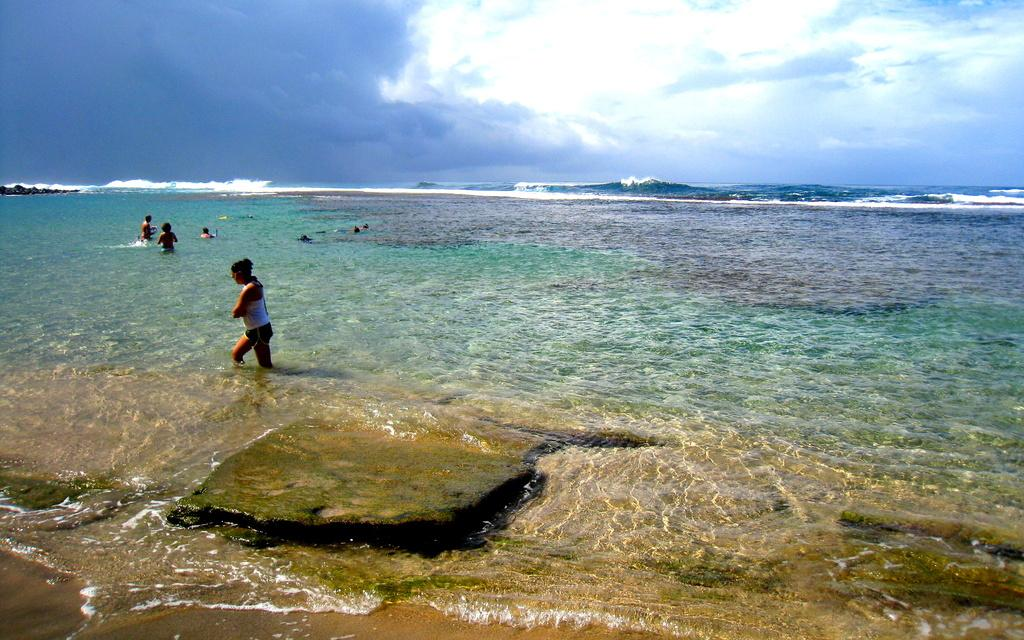What are the people in the image doing? The people in the image are in the water. What can be seen in the background of the image? The sky is visible in the background of the image. What is the condition of the sky in the image? Clouds are present in the sky. What type of branch can be seen growing from the yam in the image? There is no branch or yam present in the image; it features people in the water with a visible sky and clouds. 